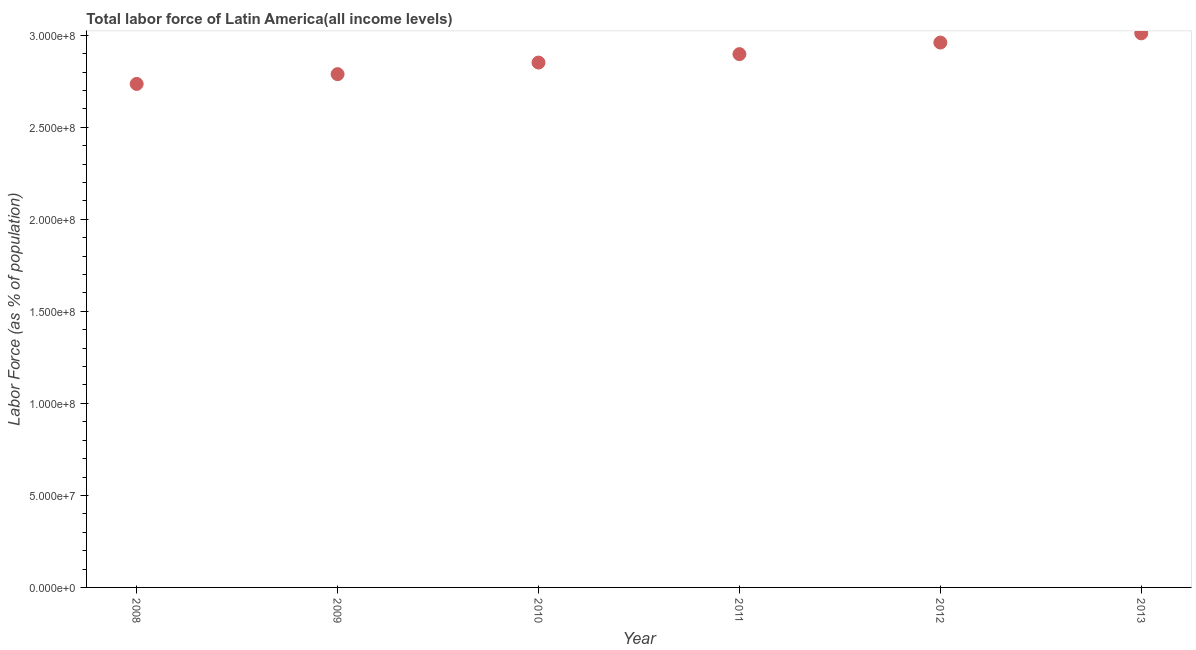What is the total labor force in 2010?
Provide a short and direct response. 2.85e+08. Across all years, what is the maximum total labor force?
Keep it short and to the point. 3.01e+08. Across all years, what is the minimum total labor force?
Your answer should be very brief. 2.74e+08. What is the sum of the total labor force?
Your response must be concise. 1.72e+09. What is the difference between the total labor force in 2010 and 2013?
Provide a succinct answer. -1.59e+07. What is the average total labor force per year?
Give a very brief answer. 2.87e+08. What is the median total labor force?
Keep it short and to the point. 2.87e+08. In how many years, is the total labor force greater than 140000000 %?
Your answer should be very brief. 6. Do a majority of the years between 2013 and 2008 (inclusive) have total labor force greater than 250000000 %?
Your answer should be very brief. Yes. What is the ratio of the total labor force in 2008 to that in 2010?
Provide a succinct answer. 0.96. Is the total labor force in 2011 less than that in 2013?
Offer a very short reply. Yes. Is the difference between the total labor force in 2008 and 2010 greater than the difference between any two years?
Give a very brief answer. No. What is the difference between the highest and the second highest total labor force?
Make the answer very short. 5.01e+06. What is the difference between the highest and the lowest total labor force?
Your answer should be compact. 2.75e+07. How many years are there in the graph?
Keep it short and to the point. 6. Does the graph contain any zero values?
Provide a short and direct response. No. Does the graph contain grids?
Give a very brief answer. No. What is the title of the graph?
Offer a very short reply. Total labor force of Latin America(all income levels). What is the label or title of the Y-axis?
Offer a very short reply. Labor Force (as % of population). What is the Labor Force (as % of population) in 2008?
Offer a very short reply. 2.74e+08. What is the Labor Force (as % of population) in 2009?
Your response must be concise. 2.79e+08. What is the Labor Force (as % of population) in 2010?
Make the answer very short. 2.85e+08. What is the Labor Force (as % of population) in 2011?
Ensure brevity in your answer.  2.90e+08. What is the Labor Force (as % of population) in 2012?
Offer a terse response. 2.96e+08. What is the Labor Force (as % of population) in 2013?
Provide a short and direct response. 3.01e+08. What is the difference between the Labor Force (as % of population) in 2008 and 2009?
Keep it short and to the point. -5.30e+06. What is the difference between the Labor Force (as % of population) in 2008 and 2010?
Provide a short and direct response. -1.16e+07. What is the difference between the Labor Force (as % of population) in 2008 and 2011?
Provide a short and direct response. -1.62e+07. What is the difference between the Labor Force (as % of population) in 2008 and 2012?
Provide a short and direct response. -2.25e+07. What is the difference between the Labor Force (as % of population) in 2008 and 2013?
Give a very brief answer. -2.75e+07. What is the difference between the Labor Force (as % of population) in 2009 and 2010?
Your answer should be very brief. -6.30e+06. What is the difference between the Labor Force (as % of population) in 2009 and 2011?
Make the answer very short. -1.09e+07. What is the difference between the Labor Force (as % of population) in 2009 and 2012?
Offer a terse response. -1.72e+07. What is the difference between the Labor Force (as % of population) in 2009 and 2013?
Provide a short and direct response. -2.22e+07. What is the difference between the Labor Force (as % of population) in 2010 and 2011?
Give a very brief answer. -4.59e+06. What is the difference between the Labor Force (as % of population) in 2010 and 2012?
Provide a short and direct response. -1.09e+07. What is the difference between the Labor Force (as % of population) in 2010 and 2013?
Your response must be concise. -1.59e+07. What is the difference between the Labor Force (as % of population) in 2011 and 2012?
Your answer should be very brief. -6.27e+06. What is the difference between the Labor Force (as % of population) in 2011 and 2013?
Keep it short and to the point. -1.13e+07. What is the difference between the Labor Force (as % of population) in 2012 and 2013?
Keep it short and to the point. -5.01e+06. What is the ratio of the Labor Force (as % of population) in 2008 to that in 2010?
Your answer should be compact. 0.96. What is the ratio of the Labor Force (as % of population) in 2008 to that in 2011?
Keep it short and to the point. 0.94. What is the ratio of the Labor Force (as % of population) in 2008 to that in 2012?
Your answer should be very brief. 0.92. What is the ratio of the Labor Force (as % of population) in 2008 to that in 2013?
Your answer should be compact. 0.91. What is the ratio of the Labor Force (as % of population) in 2009 to that in 2010?
Keep it short and to the point. 0.98. What is the ratio of the Labor Force (as % of population) in 2009 to that in 2012?
Give a very brief answer. 0.94. What is the ratio of the Labor Force (as % of population) in 2009 to that in 2013?
Offer a very short reply. 0.93. What is the ratio of the Labor Force (as % of population) in 2010 to that in 2011?
Make the answer very short. 0.98. What is the ratio of the Labor Force (as % of population) in 2010 to that in 2012?
Give a very brief answer. 0.96. What is the ratio of the Labor Force (as % of population) in 2010 to that in 2013?
Your response must be concise. 0.95. What is the ratio of the Labor Force (as % of population) in 2011 to that in 2012?
Ensure brevity in your answer.  0.98. What is the ratio of the Labor Force (as % of population) in 2011 to that in 2013?
Provide a short and direct response. 0.96. What is the ratio of the Labor Force (as % of population) in 2012 to that in 2013?
Your answer should be very brief. 0.98. 